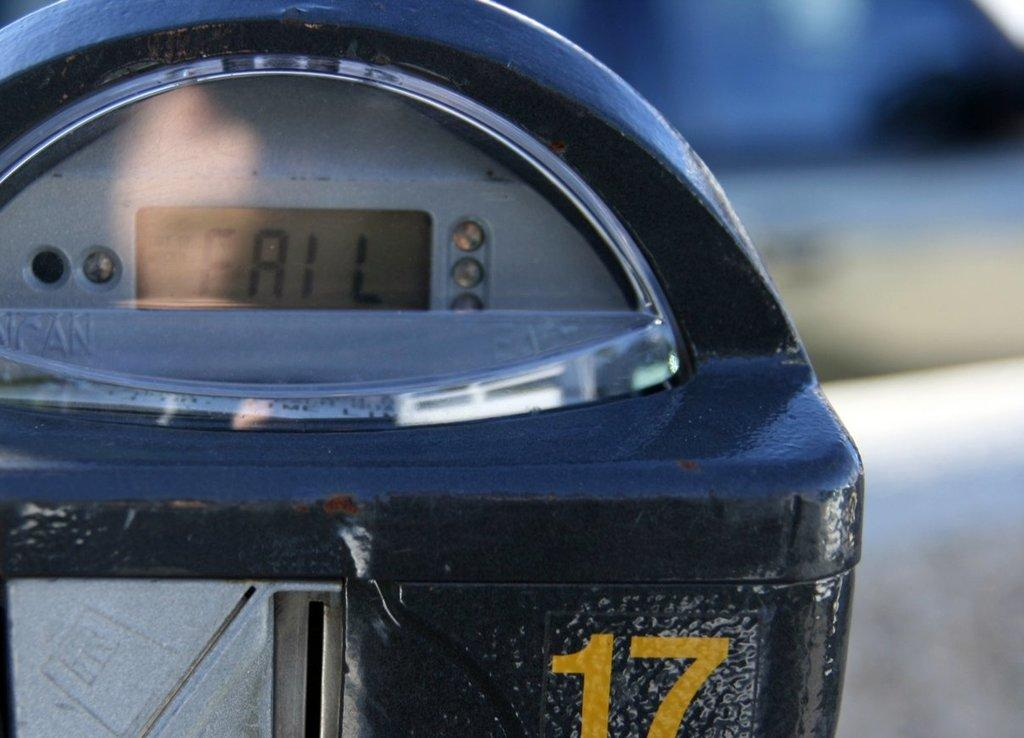<image>
Present a compact description of the photo's key features. A parking read reads FAIL on its display. 